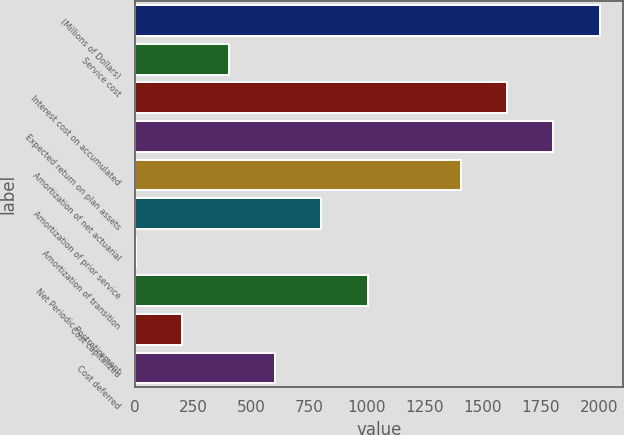<chart> <loc_0><loc_0><loc_500><loc_500><bar_chart><fcel>(Millions of Dollars)<fcel>Service cost<fcel>Interest cost on accumulated<fcel>Expected return on plan assets<fcel>Amortization of net actuarial<fcel>Amortization of prior service<fcel>Amortization of transition<fcel>Net Periodic Postretirement<fcel>Cost capitalized<fcel>Cost deferred<nl><fcel>2004<fcel>404<fcel>1604<fcel>1804<fcel>1404<fcel>804<fcel>4<fcel>1004<fcel>204<fcel>604<nl></chart> 